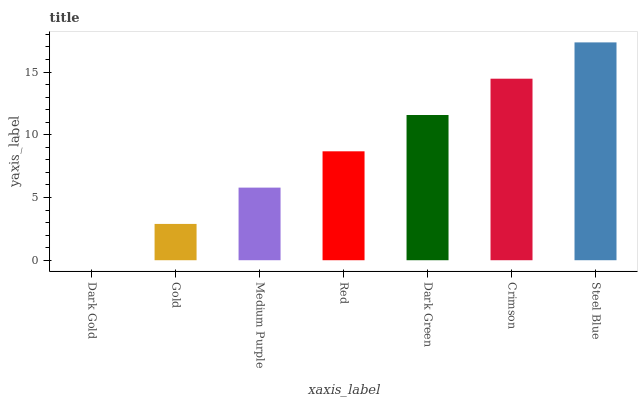Is Dark Gold the minimum?
Answer yes or no. Yes. Is Steel Blue the maximum?
Answer yes or no. Yes. Is Gold the minimum?
Answer yes or no. No. Is Gold the maximum?
Answer yes or no. No. Is Gold greater than Dark Gold?
Answer yes or no. Yes. Is Dark Gold less than Gold?
Answer yes or no. Yes. Is Dark Gold greater than Gold?
Answer yes or no. No. Is Gold less than Dark Gold?
Answer yes or no. No. Is Red the high median?
Answer yes or no. Yes. Is Red the low median?
Answer yes or no. Yes. Is Dark Gold the high median?
Answer yes or no. No. Is Crimson the low median?
Answer yes or no. No. 